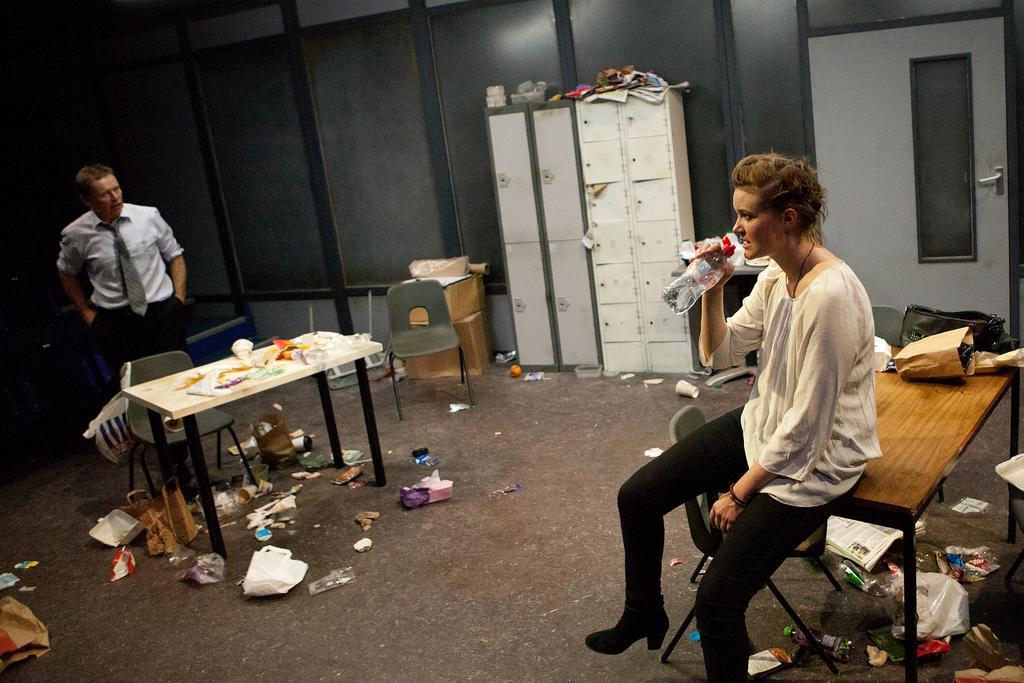Can you describe this image briefly? There is a room. The two persons are in a room. On the right side we have a person. He is sitting on a table. He is holding bottle. On the left side we have a another person. He is wearing a tie. There is a table. There is a bag on a table. We can see in background lockers and cupboards,boxes. 